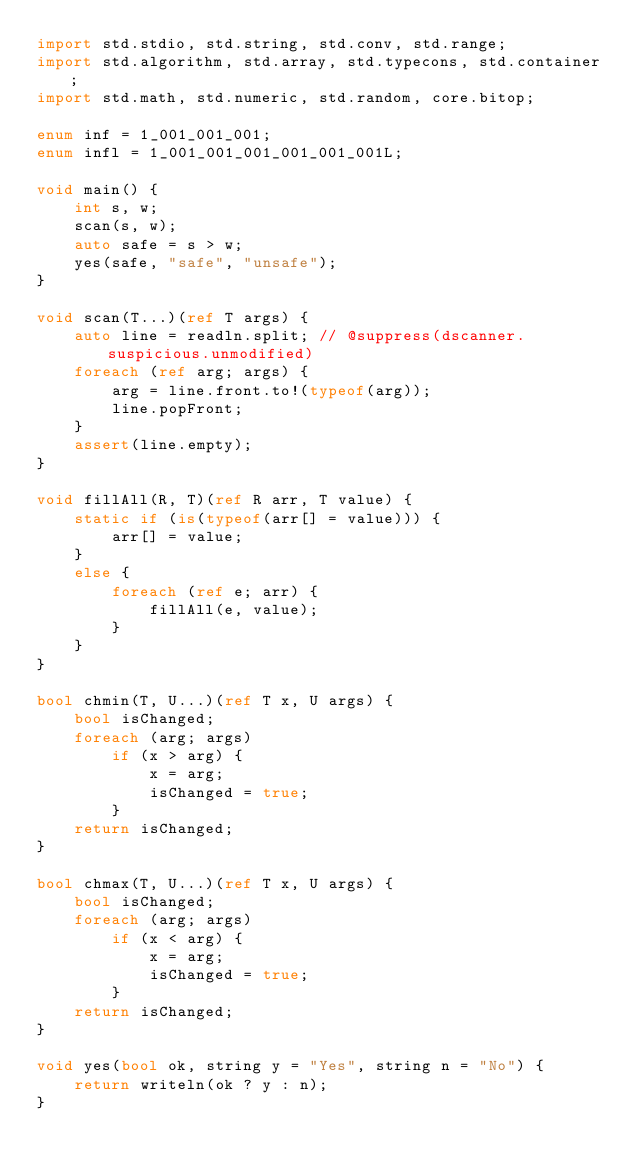Convert code to text. <code><loc_0><loc_0><loc_500><loc_500><_D_>import std.stdio, std.string, std.conv, std.range;
import std.algorithm, std.array, std.typecons, std.container;
import std.math, std.numeric, std.random, core.bitop;

enum inf = 1_001_001_001;
enum infl = 1_001_001_001_001_001_001L;

void main() {
    int s, w;
    scan(s, w);
    auto safe = s > w;
    yes(safe, "safe", "unsafe");
}

void scan(T...)(ref T args) {
    auto line = readln.split; // @suppress(dscanner.suspicious.unmodified)
    foreach (ref arg; args) {
        arg = line.front.to!(typeof(arg));
        line.popFront;
    }
    assert(line.empty);
}

void fillAll(R, T)(ref R arr, T value) {
    static if (is(typeof(arr[] = value))) {
        arr[] = value;
    }
    else {
        foreach (ref e; arr) {
            fillAll(e, value);
        }
    }
}

bool chmin(T, U...)(ref T x, U args) {
    bool isChanged;
    foreach (arg; args)
        if (x > arg) {
            x = arg;
            isChanged = true;
        }
    return isChanged;
}

bool chmax(T, U...)(ref T x, U args) {
    bool isChanged;
    foreach (arg; args)
        if (x < arg) {
            x = arg;
            isChanged = true;
        }
    return isChanged;
}

void yes(bool ok, string y = "Yes", string n = "No") {
    return writeln(ok ? y : n);
}
</code> 